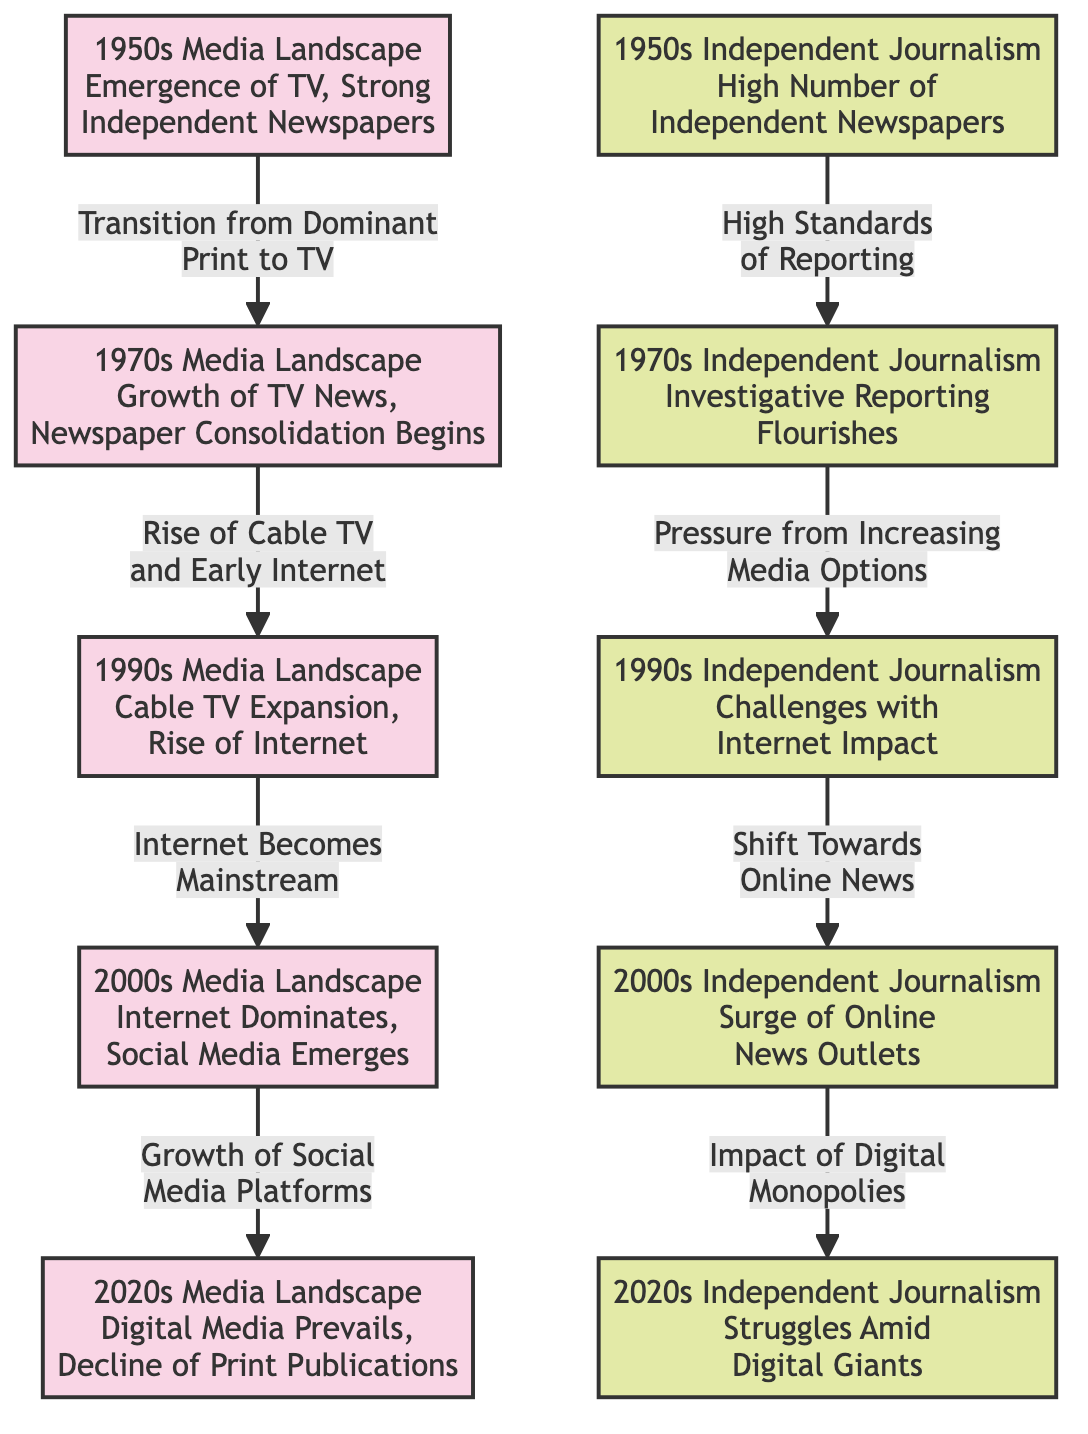What media landscape change occurred between the 1950s and 1970s? The transition from dominant print media to television is described, indicating a significant shift in how news was consumed and presented.
Answer: Transition from Dominant Print to TV What does the 1990s media landscape depict? The 1990s media landscape illustrates the expansion of cable television and the rise of the internet, suggesting a diversification of media sources during that decade.
Answer: Cable TV Expansion, Rise of Internet How did independent journalism in the 1970s affect the following decade? The high standards of reporting in the 1970s led to pressures from increasing media options in the 1990s, signifying a challenging environment for journalists.
Answer: Pressure from Increasing Media Options How many decades are represented in this diagram? The diagram shows five distinct decades from the 1950s to the 2020s, each capturing a different media landscape and state of independent journalism.
Answer: Five What is the primary reason for the decline of independent journalism in the 2020s? The diagram indicates that the struggles of independent journalism in the 2020s are primarily due to the presence of digital giants, which dominate the media landscape and impede the survival of smaller outlets.
Answer: Impact of Digital Monopolies What major media development took place in the 2000s? The 2000s media landscape is noted for the dominance of the internet and the emergence of social media, which fundamentally changed how news was disseminated and consumed.
Answer: Internet Dominates, Social Media Emerges What directly caused independent journalism to shift towards online news in the 2000s? The shift towards online news in the 2000s was a result of earlier challenges faced by independent journalism in the 1990s due to the internet's impact on traditional news consumption.
Answer: Shift Towards Online News Which decade represents a high number of independent newspapers? The 1950s are highlighted as the period with a high number of independent newspapers, signifying a robust independent journalism environment during that time.
Answer: 1950s Independent Journalism What does the arrow from the media landscape of the 2000s to the 2020s indicate? The arrow signifies a growth of social media platforms that continued to shape and challenge the media landscape, leading into the struggles faced in the 2020s.
Answer: Growth of Social Media Platforms 